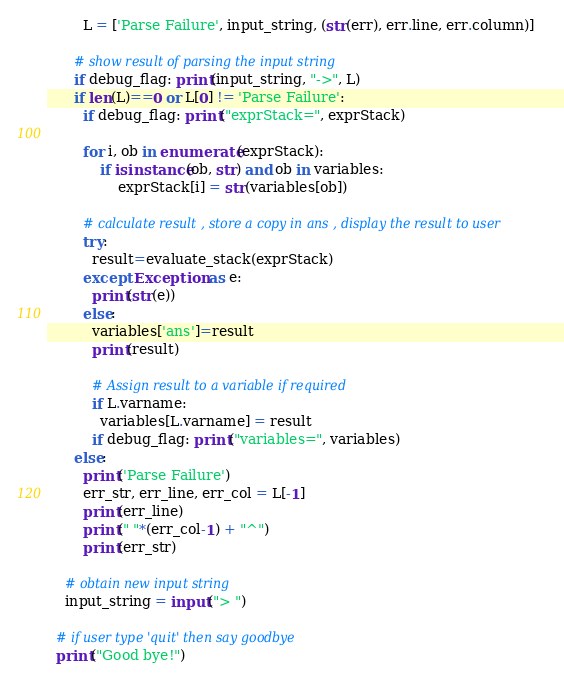<code> <loc_0><loc_0><loc_500><loc_500><_Python_>        L = ['Parse Failure', input_string, (str(err), err.line, err.column)]

      # show result of parsing the input string
      if debug_flag: print(input_string, "->", L)
      if len(L)==0 or L[0] != 'Parse Failure':
        if debug_flag: print("exprStack=", exprStack)

        for i, ob in enumerate(exprStack):
            if isinstance(ob, str) and ob in variables:
                exprStack[i] = str(variables[ob])

        # calculate result , store a copy in ans , display the result to user
        try:
          result=evaluate_stack(exprStack)
        except Exception as e:
          print(str(e))
        else:
          variables['ans']=result
          print(result)

          # Assign result to a variable if required
          if L.varname:
            variables[L.varname] = result
          if debug_flag: print("variables=", variables)
      else:
        print('Parse Failure')
        err_str, err_line, err_col = L[-1]
        print(err_line)
        print(" "*(err_col-1) + "^")
        print(err_str)

    # obtain new input string
    input_string = input("> ")

  # if user type 'quit' then say goodbye
  print("Good bye!")
</code> 